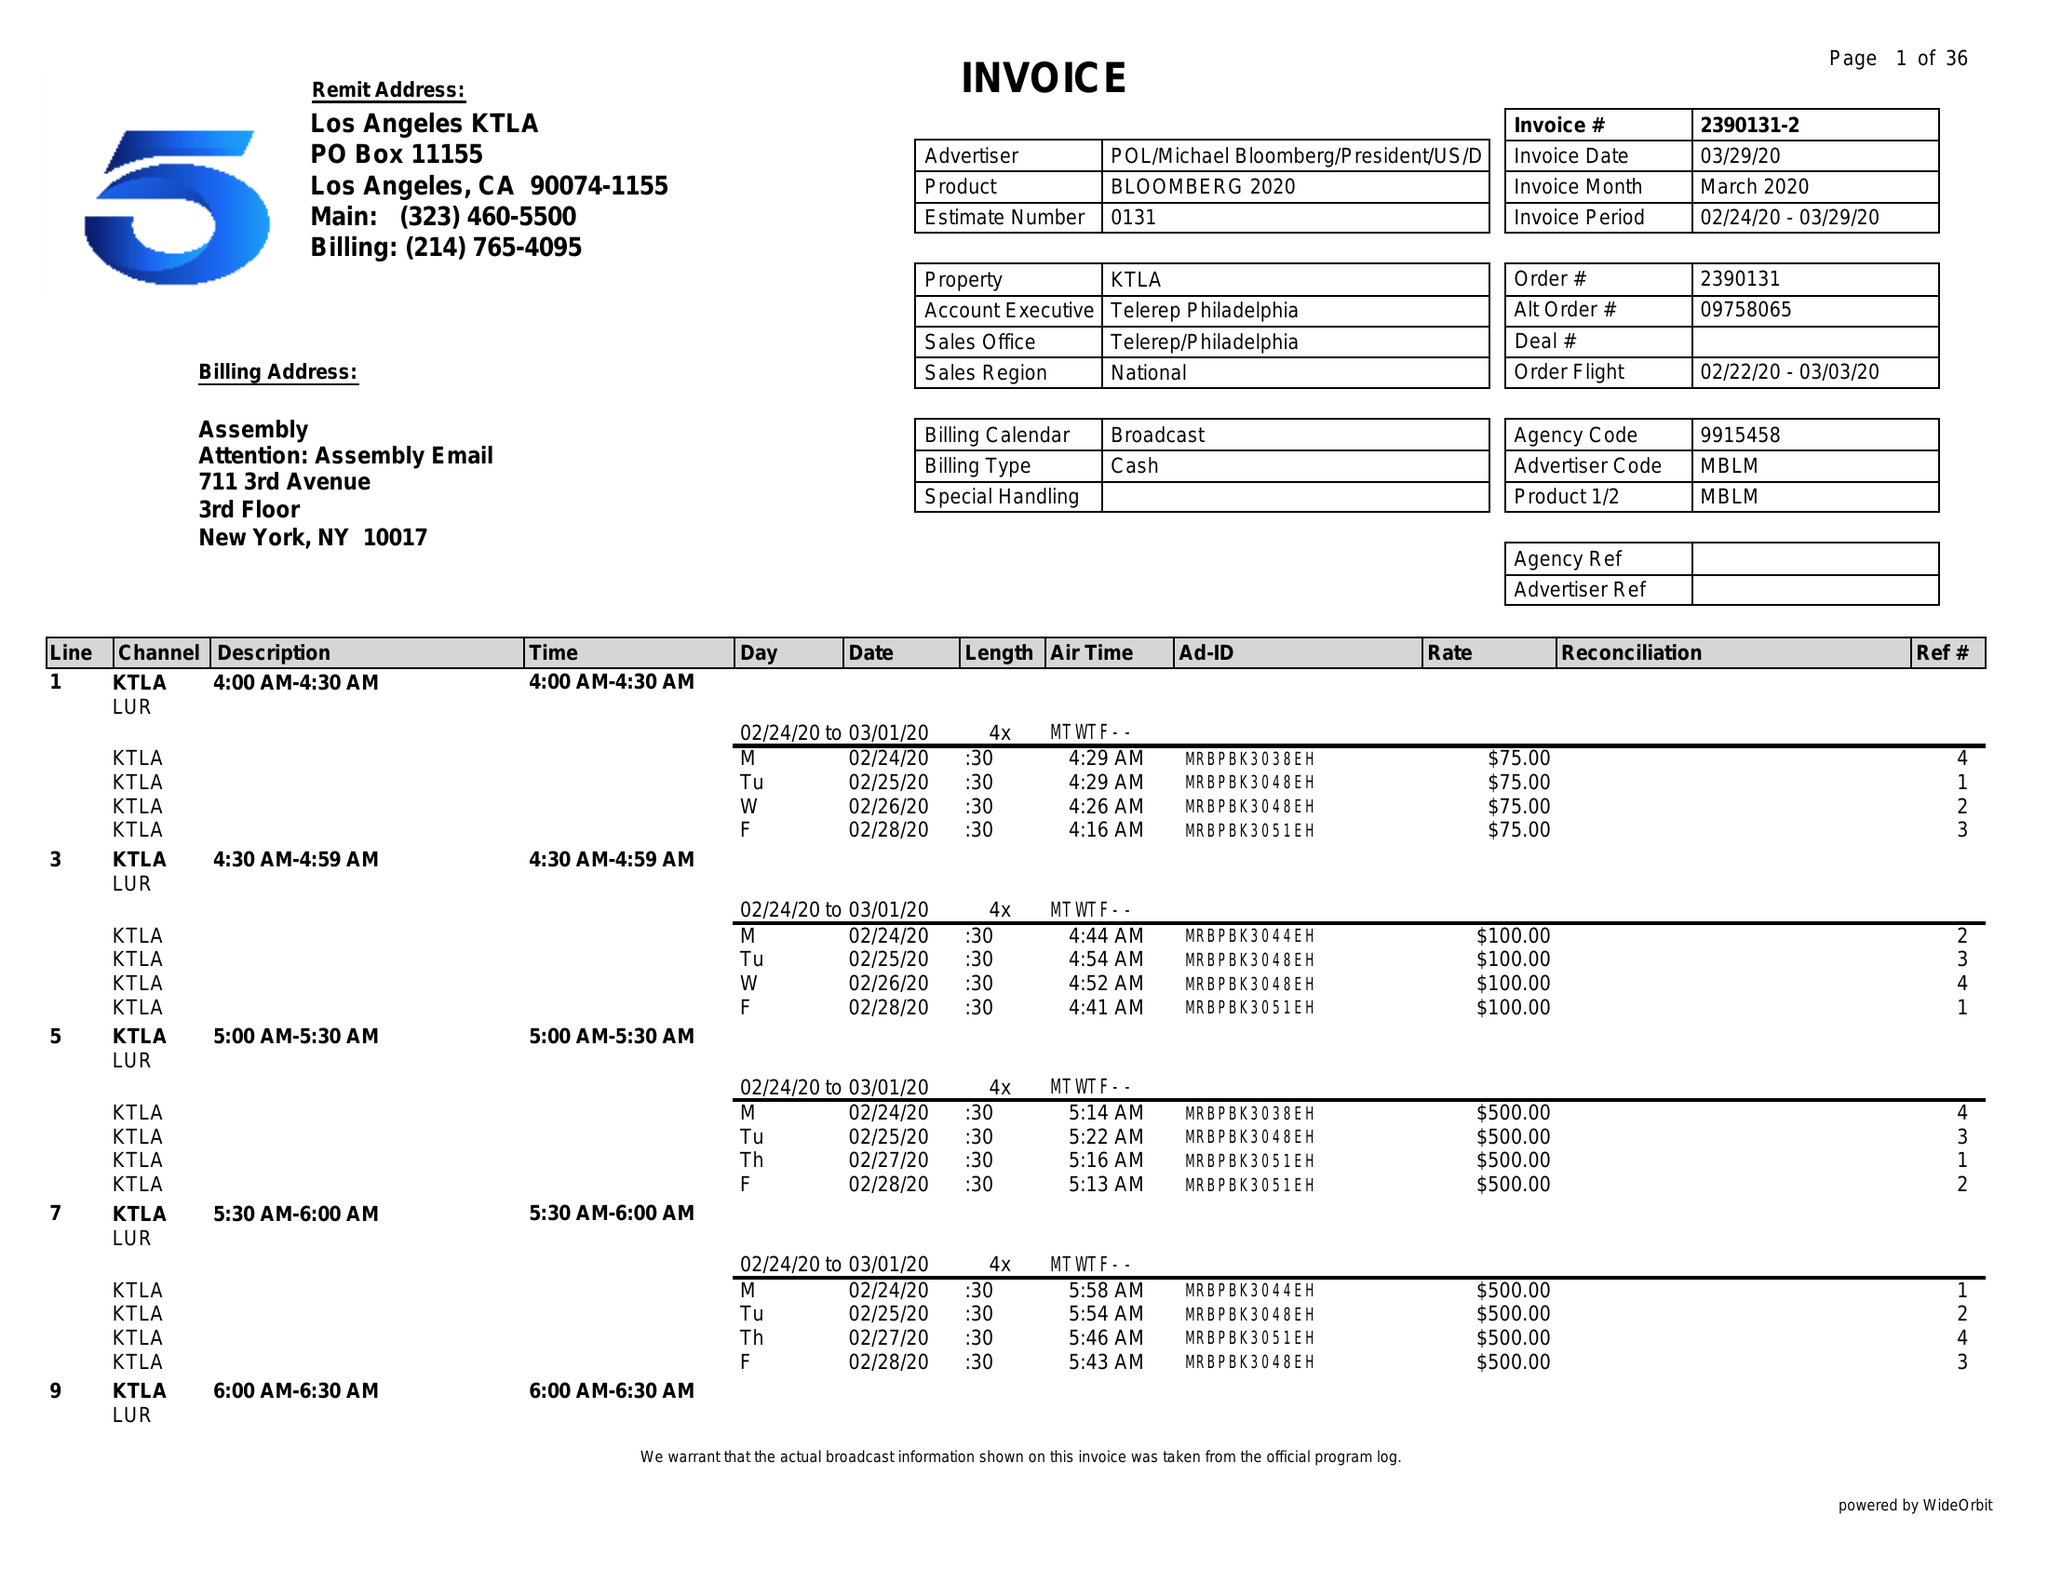What is the value for the contract_num?
Answer the question using a single word or phrase. 2390131 